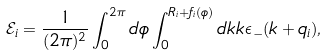Convert formula to latex. <formula><loc_0><loc_0><loc_500><loc_500>\mathcal { E } _ { i } = \frac { 1 } { ( 2 \pi ) ^ { 2 } } \int _ { 0 } ^ { 2 \pi } d \phi \int _ { 0 } ^ { R _ { i } + f _ { i } ( \phi ) } d k k \epsilon _ { - } ( k + q _ { i } ) ,</formula> 